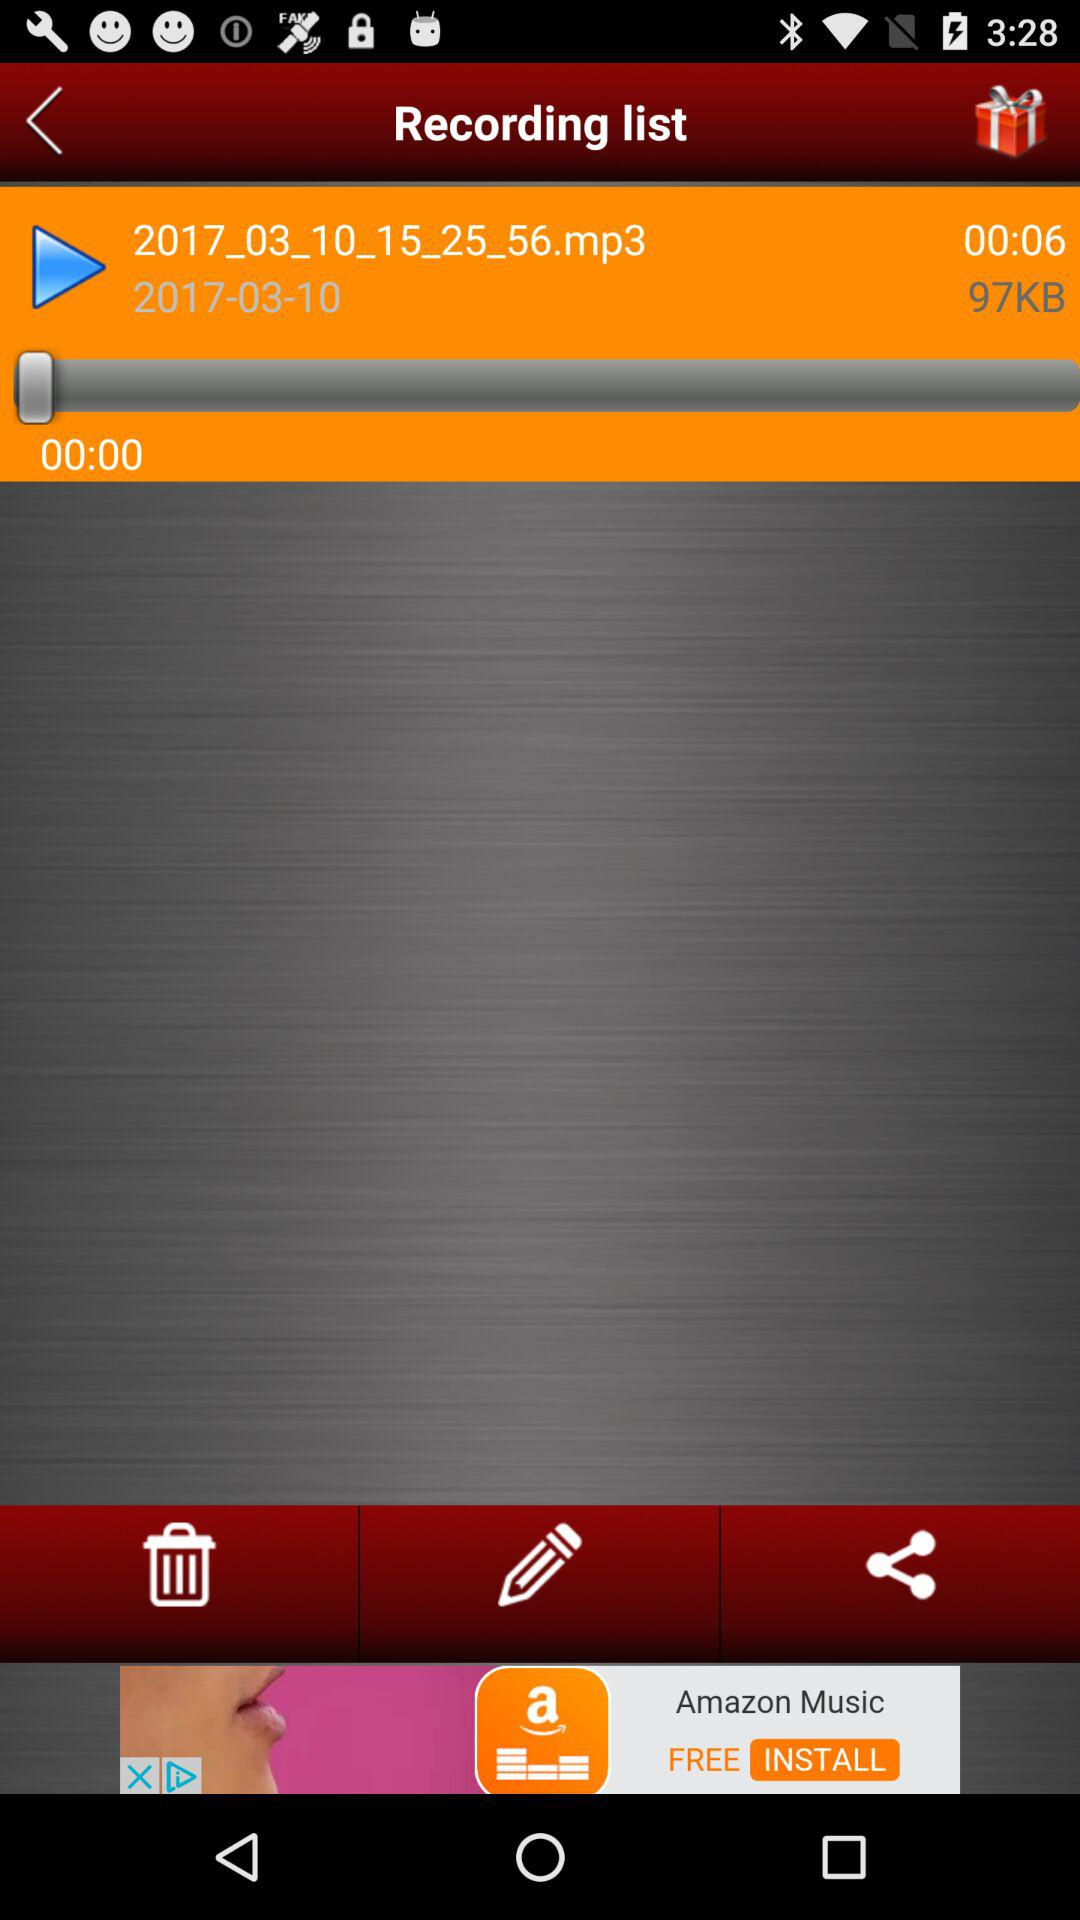What is the total length of the audio? The total length of the audio is 6 seconds. 